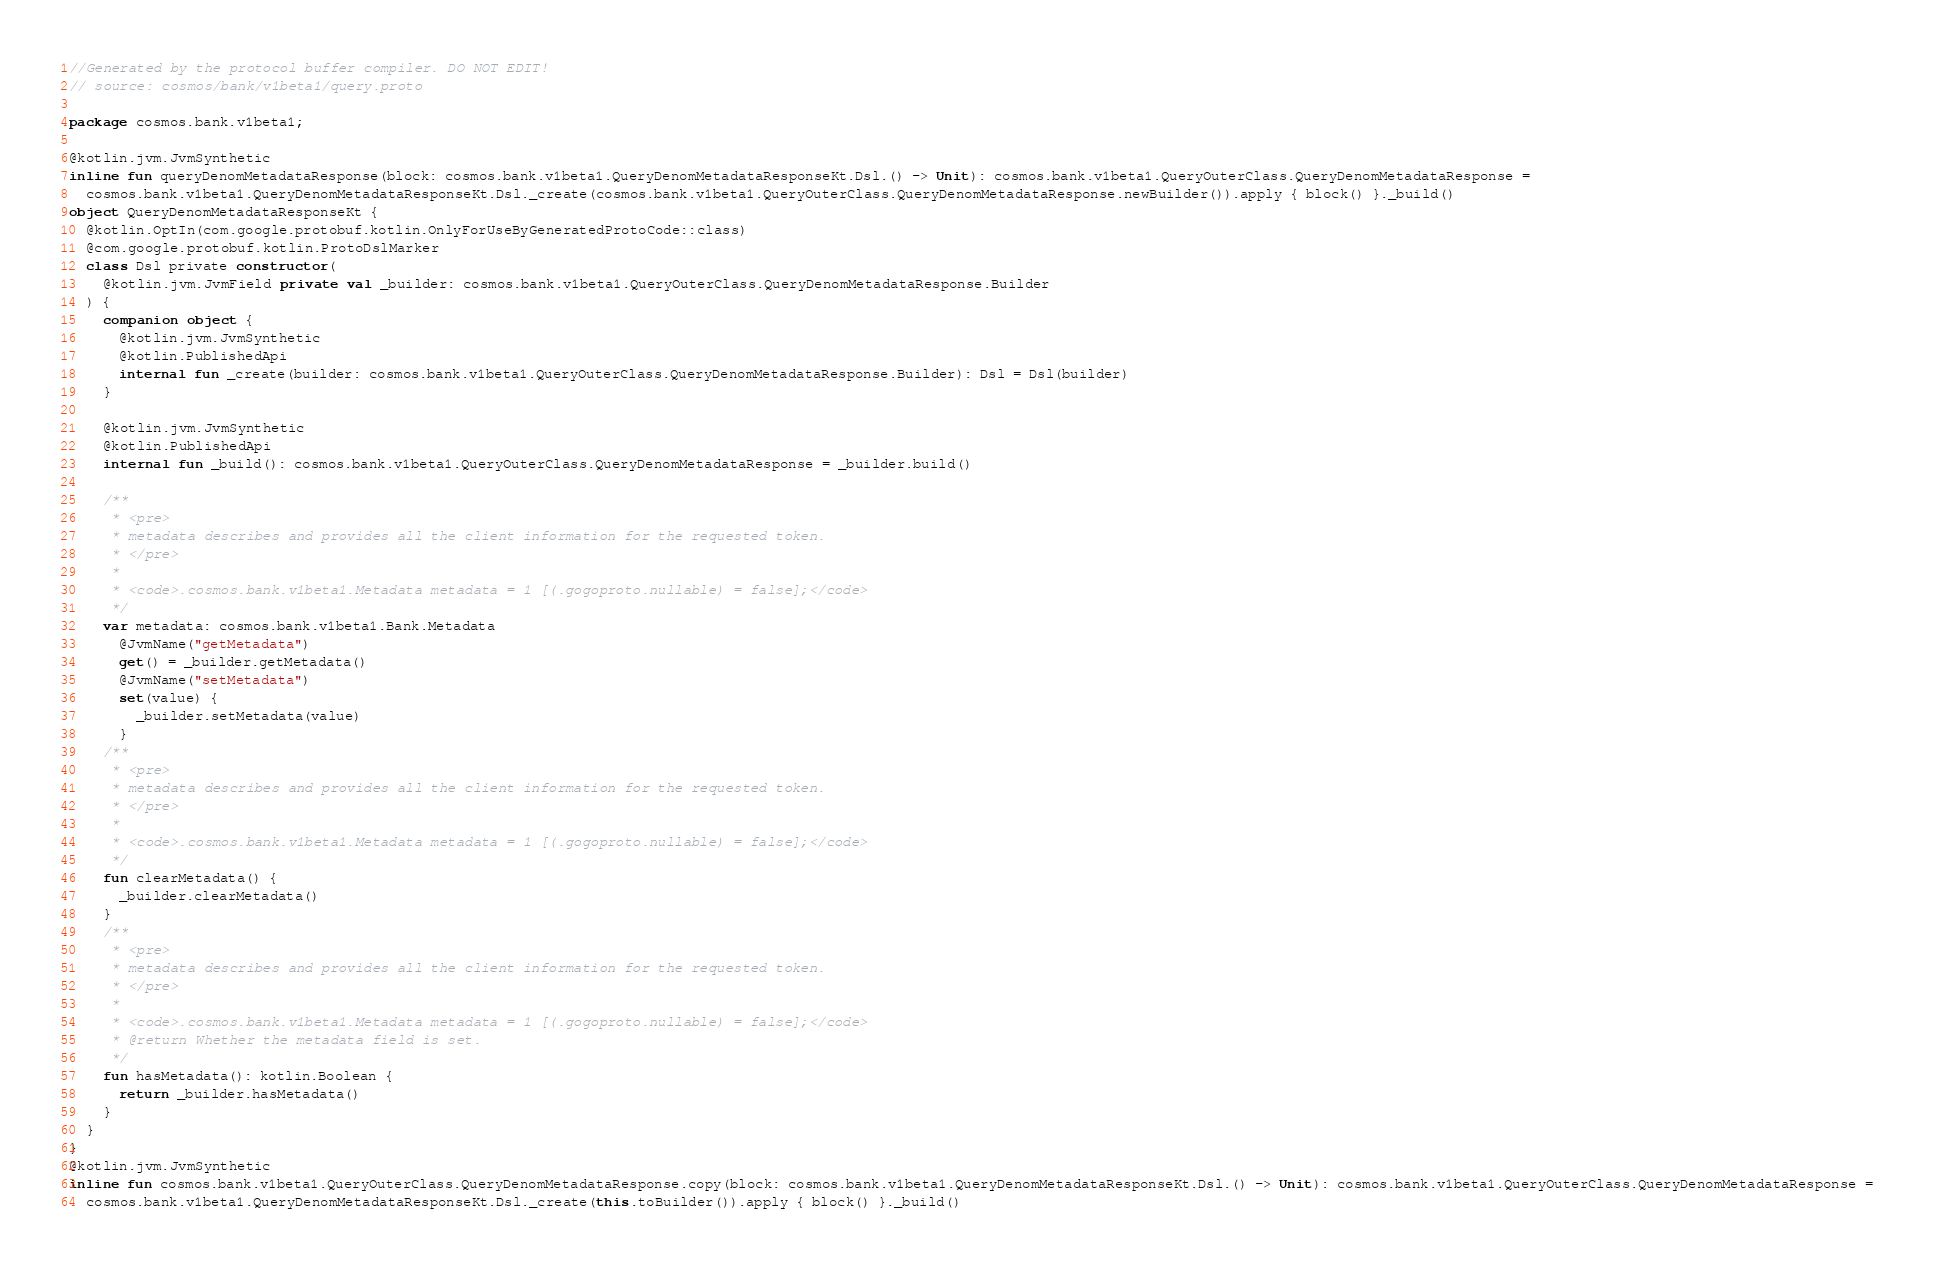Convert code to text. <code><loc_0><loc_0><loc_500><loc_500><_Kotlin_>//Generated by the protocol buffer compiler. DO NOT EDIT!
// source: cosmos/bank/v1beta1/query.proto

package cosmos.bank.v1beta1;

@kotlin.jvm.JvmSynthetic
inline fun queryDenomMetadataResponse(block: cosmos.bank.v1beta1.QueryDenomMetadataResponseKt.Dsl.() -> Unit): cosmos.bank.v1beta1.QueryOuterClass.QueryDenomMetadataResponse =
  cosmos.bank.v1beta1.QueryDenomMetadataResponseKt.Dsl._create(cosmos.bank.v1beta1.QueryOuterClass.QueryDenomMetadataResponse.newBuilder()).apply { block() }._build()
object QueryDenomMetadataResponseKt {
  @kotlin.OptIn(com.google.protobuf.kotlin.OnlyForUseByGeneratedProtoCode::class)
  @com.google.protobuf.kotlin.ProtoDslMarker
  class Dsl private constructor(
    @kotlin.jvm.JvmField private val _builder: cosmos.bank.v1beta1.QueryOuterClass.QueryDenomMetadataResponse.Builder
  ) {
    companion object {
      @kotlin.jvm.JvmSynthetic
      @kotlin.PublishedApi
      internal fun _create(builder: cosmos.bank.v1beta1.QueryOuterClass.QueryDenomMetadataResponse.Builder): Dsl = Dsl(builder)
    }

    @kotlin.jvm.JvmSynthetic
    @kotlin.PublishedApi
    internal fun _build(): cosmos.bank.v1beta1.QueryOuterClass.QueryDenomMetadataResponse = _builder.build()

    /**
     * <pre>
     * metadata describes and provides all the client information for the requested token.
     * </pre>
     *
     * <code>.cosmos.bank.v1beta1.Metadata metadata = 1 [(.gogoproto.nullable) = false];</code>
     */
    var metadata: cosmos.bank.v1beta1.Bank.Metadata
      @JvmName("getMetadata")
      get() = _builder.getMetadata()
      @JvmName("setMetadata")
      set(value) {
        _builder.setMetadata(value)
      }
    /**
     * <pre>
     * metadata describes and provides all the client information for the requested token.
     * </pre>
     *
     * <code>.cosmos.bank.v1beta1.Metadata metadata = 1 [(.gogoproto.nullable) = false];</code>
     */
    fun clearMetadata() {
      _builder.clearMetadata()
    }
    /**
     * <pre>
     * metadata describes and provides all the client information for the requested token.
     * </pre>
     *
     * <code>.cosmos.bank.v1beta1.Metadata metadata = 1 [(.gogoproto.nullable) = false];</code>
     * @return Whether the metadata field is set.
     */
    fun hasMetadata(): kotlin.Boolean {
      return _builder.hasMetadata()
    }
  }
}
@kotlin.jvm.JvmSynthetic
inline fun cosmos.bank.v1beta1.QueryOuterClass.QueryDenomMetadataResponse.copy(block: cosmos.bank.v1beta1.QueryDenomMetadataResponseKt.Dsl.() -> Unit): cosmos.bank.v1beta1.QueryOuterClass.QueryDenomMetadataResponse =
  cosmos.bank.v1beta1.QueryDenomMetadataResponseKt.Dsl._create(this.toBuilder()).apply { block() }._build()
</code> 